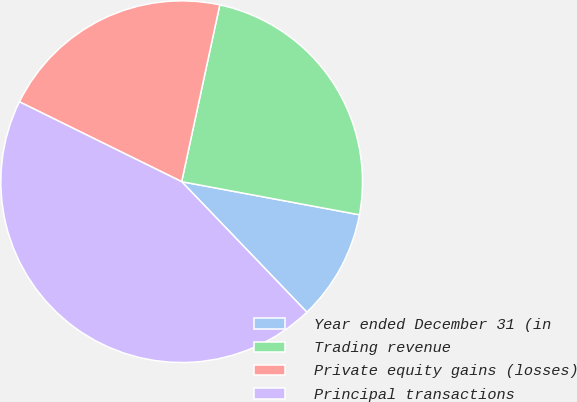Convert chart to OTSL. <chart><loc_0><loc_0><loc_500><loc_500><pie_chart><fcel>Year ended December 31 (in<fcel>Trading revenue<fcel>Private equity gains (losses)<fcel>Principal transactions<nl><fcel>9.9%<fcel>24.55%<fcel>21.1%<fcel>44.45%<nl></chart> 